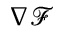Convert formula to latex. <formula><loc_0><loc_0><loc_500><loc_500>\nabla { \mathcal { F } }</formula> 